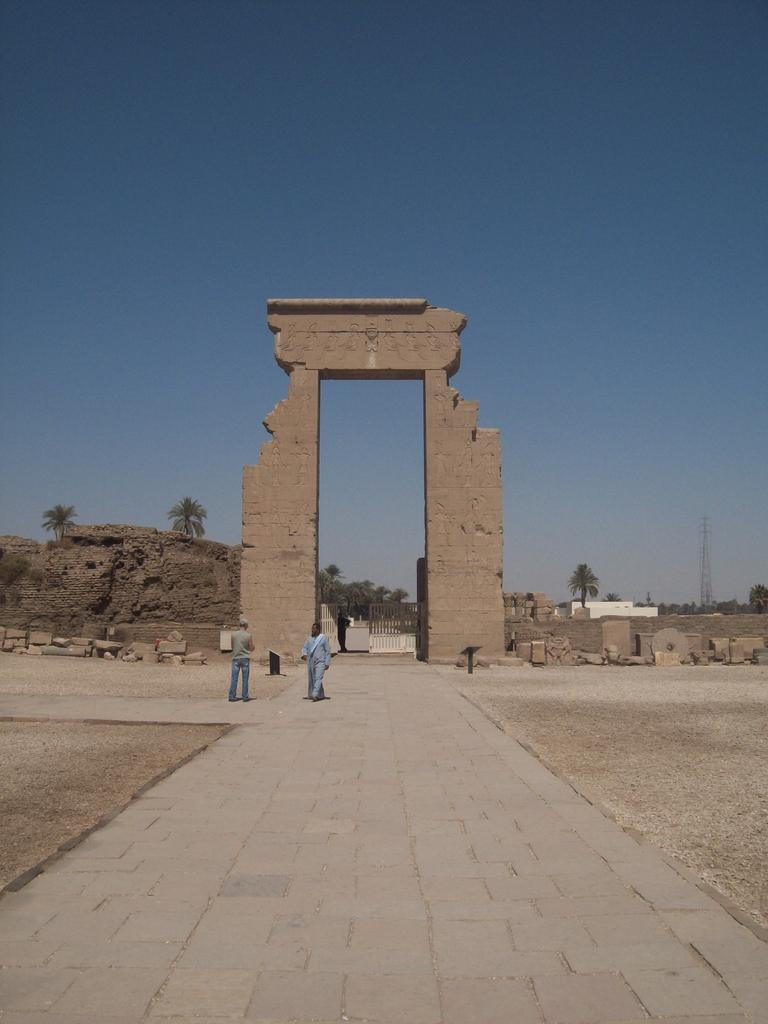How many people are standing on the road in the image? There are two people standing on the road in the image. What can be seen in the background behind the people? There is an arch, many trees, a tower, and a blue sky visible in the background. What type of spoon is the governor using in the image? There is no governor or spoon present in the image. 